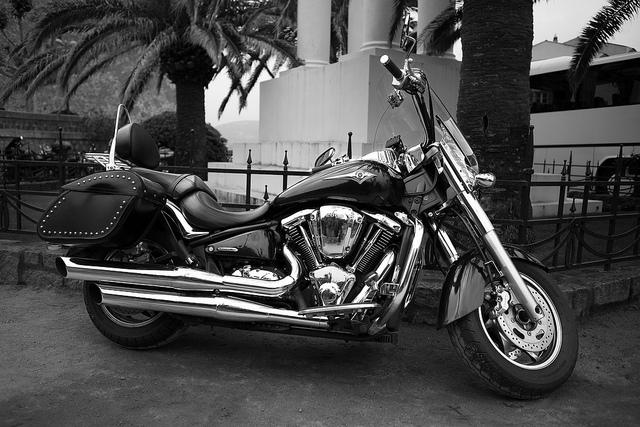Is this a color picture?
Short answer required. No. What is the vehicle parked next to?
Keep it brief. Fence. What vehicle is this?
Quick response, please. Motorcycle. 